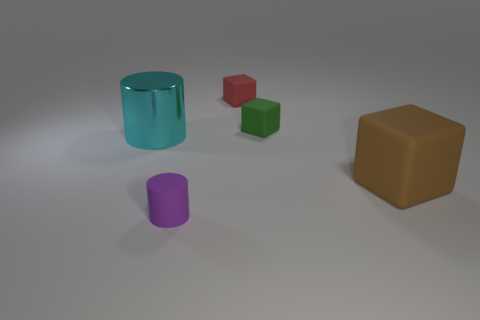How is the lighting arranged in this scene? The lighting in this scene appears to be diffused, coming from a source above the objects, casting soft shadows directly beneath them without harsh contrasts, suggesting an indoor environment with possibly overhead ambient lighting. 